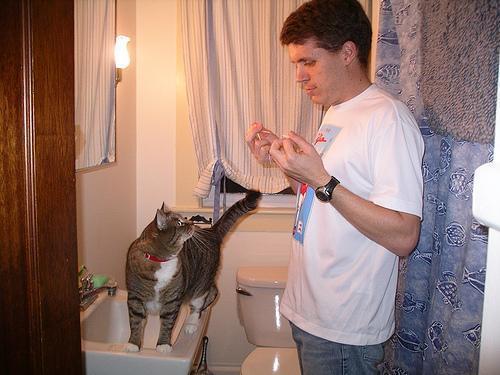How many people are there?
Give a very brief answer. 1. How many horses are in the photo?
Give a very brief answer. 0. 